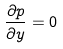Convert formula to latex. <formula><loc_0><loc_0><loc_500><loc_500>\frac { \partial p } { \partial y } = 0</formula> 